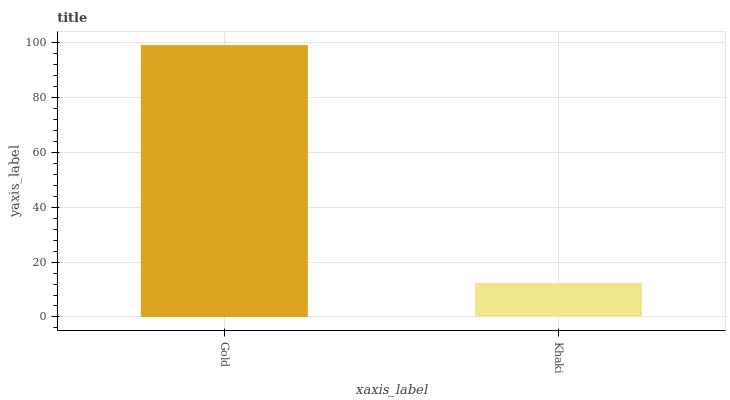Is Khaki the minimum?
Answer yes or no. Yes. Is Gold the maximum?
Answer yes or no. Yes. Is Khaki the maximum?
Answer yes or no. No. Is Gold greater than Khaki?
Answer yes or no. Yes. Is Khaki less than Gold?
Answer yes or no. Yes. Is Khaki greater than Gold?
Answer yes or no. No. Is Gold less than Khaki?
Answer yes or no. No. Is Gold the high median?
Answer yes or no. Yes. Is Khaki the low median?
Answer yes or no. Yes. Is Khaki the high median?
Answer yes or no. No. Is Gold the low median?
Answer yes or no. No. 